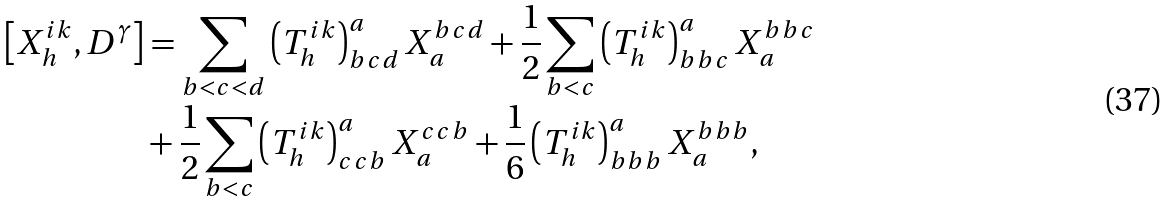<formula> <loc_0><loc_0><loc_500><loc_500>\left [ X _ { h } ^ { i k } , D ^ { \gamma } \right ] & = \sum _ { b < c < d } \left ( T _ { h } ^ { i k } \right ) _ { b c d } ^ { a } X _ { a } ^ { b c d } + \frac { 1 } { 2 } \sum _ { b < c } \left ( T _ { h } ^ { i k } \right ) _ { b b c } ^ { a } X _ { a } ^ { b b c } \\ & + \frac { 1 } { 2 } \sum _ { b < c } \left ( T _ { h } ^ { i k } \right ) _ { c c b } ^ { a } X _ { a } ^ { c c b } + \frac { 1 } { 6 } \left ( T _ { h } ^ { i k } \right ) _ { b b b } ^ { a } X _ { a } ^ { b b b } ,</formula> 